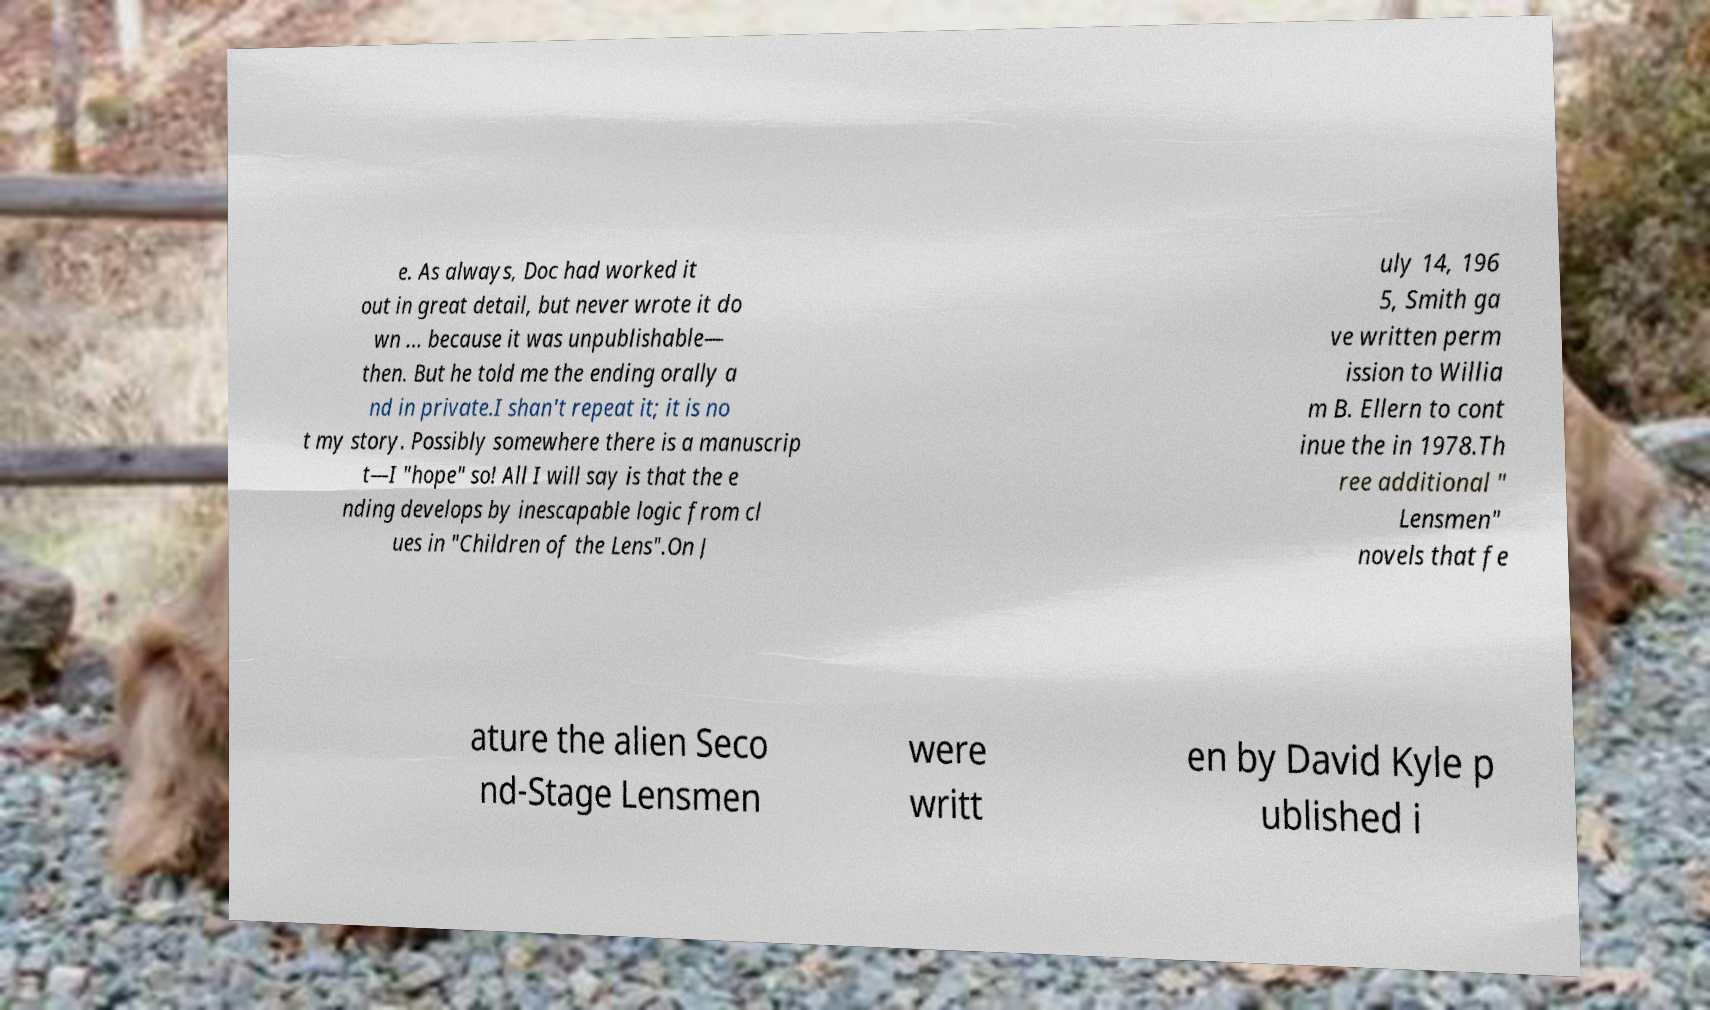Can you read and provide the text displayed in the image?This photo seems to have some interesting text. Can you extract and type it out for me? e. As always, Doc had worked it out in great detail, but never wrote it do wn ... because it was unpublishable— then. But he told me the ending orally a nd in private.I shan't repeat it; it is no t my story. Possibly somewhere there is a manuscrip t—I "hope" so! All I will say is that the e nding develops by inescapable logic from cl ues in "Children of the Lens".On J uly 14, 196 5, Smith ga ve written perm ission to Willia m B. Ellern to cont inue the in 1978.Th ree additional " Lensmen" novels that fe ature the alien Seco nd-Stage Lensmen were writt en by David Kyle p ublished i 